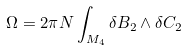Convert formula to latex. <formula><loc_0><loc_0><loc_500><loc_500>\Omega = 2 \pi N \int _ { M _ { 4 } } \delta B _ { 2 } \wedge \delta C _ { 2 }</formula> 